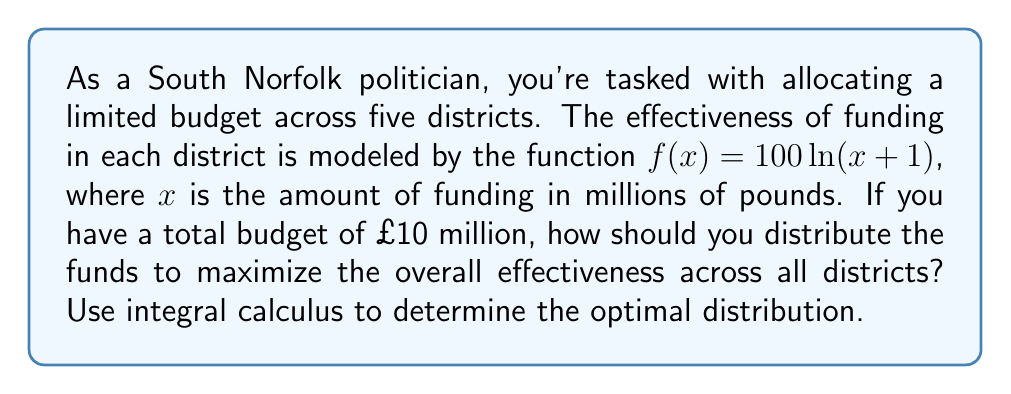Solve this math problem. To solve this problem, we'll use the method of Lagrange multipliers:

1) Let $x_i$ represent the funding for each district, where $i = 1,2,3,4,5$.

2) Our objective function is:
   $$F = \sum_{i=1}^5 f(x_i) = \sum_{i=1}^5 100\ln(x_i+1)$$

3) The constraint is:
   $$\sum_{i=1}^5 x_i = 10$$

4) Form the Lagrangian:
   $$L = \sum_{i=1}^5 100\ln(x_i+1) - \lambda(\sum_{i=1}^5 x_i - 10)$$

5) Take partial derivatives and set them equal to zero:
   $$\frac{\partial L}{\partial x_i} = \frac{100}{x_i+1} - \lambda = 0$$
   $$\frac{\partial L}{\partial \lambda} = \sum_{i=1}^5 x_i - 10 = 0$$

6) From the first equation:
   $$x_i + 1 = \frac{100}{\lambda}$$
   $$x_i = \frac{100}{\lambda} - 1$$

7) Substitute this into the constraint equation:
   $$\sum_{i=1}^5 (\frac{100}{\lambda} - 1) = 10$$
   $$5(\frac{100}{\lambda} - 1) = 10$$
   $$\frac{500}{\lambda} - 5 = 10$$
   $$\frac{500}{\lambda} = 15$$
   $$\lambda = \frac{500}{15} = \frac{100}{3}$$

8) Substitute back to find $x_i$:
   $$x_i = \frac{100}{\frac{100}{3}} - 1 = 3 - 1 = 2$$

Therefore, the optimal distribution is to allocate £2 million to each of the five districts.
Answer: £2 million per district 